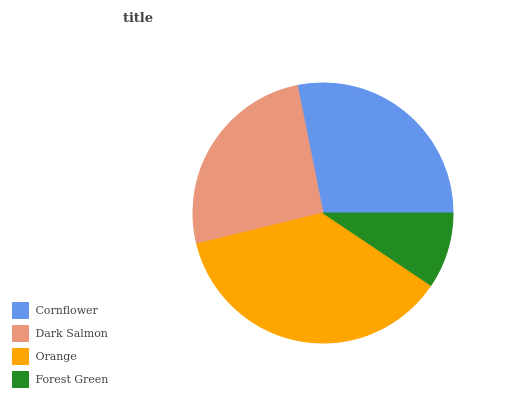Is Forest Green the minimum?
Answer yes or no. Yes. Is Orange the maximum?
Answer yes or no. Yes. Is Dark Salmon the minimum?
Answer yes or no. No. Is Dark Salmon the maximum?
Answer yes or no. No. Is Cornflower greater than Dark Salmon?
Answer yes or no. Yes. Is Dark Salmon less than Cornflower?
Answer yes or no. Yes. Is Dark Salmon greater than Cornflower?
Answer yes or no. No. Is Cornflower less than Dark Salmon?
Answer yes or no. No. Is Cornflower the high median?
Answer yes or no. Yes. Is Dark Salmon the low median?
Answer yes or no. Yes. Is Orange the high median?
Answer yes or no. No. Is Forest Green the low median?
Answer yes or no. No. 